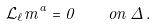<formula> <loc_0><loc_0><loc_500><loc_500>\mathcal { L } _ { \ell } m ^ { a } = 0 \, \quad o n \, \Delta \, .</formula> 